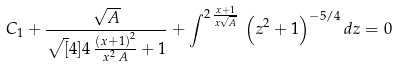Convert formula to latex. <formula><loc_0><loc_0><loc_500><loc_500>C _ { 1 } + { \frac { \sqrt { A } } { \sqrt { [ } 4 ] { 4 \, { \frac { \left ( x + 1 \right ) ^ { 2 } } { { x } ^ { 2 } \, A } } + 1 } } } + { \int } ^ { 2 \, { \frac { x + 1 } { x \sqrt { A } } } } \, \left ( { z } ^ { 2 } + 1 \right ) ^ { - 5 / 4 } { d z } = 0</formula> 